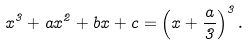Convert formula to latex. <formula><loc_0><loc_0><loc_500><loc_500>x ^ { 3 } + a x ^ { 2 } + b x + c = \left ( x + \frac { a } { 3 } \right ) ^ { 3 } .</formula> 